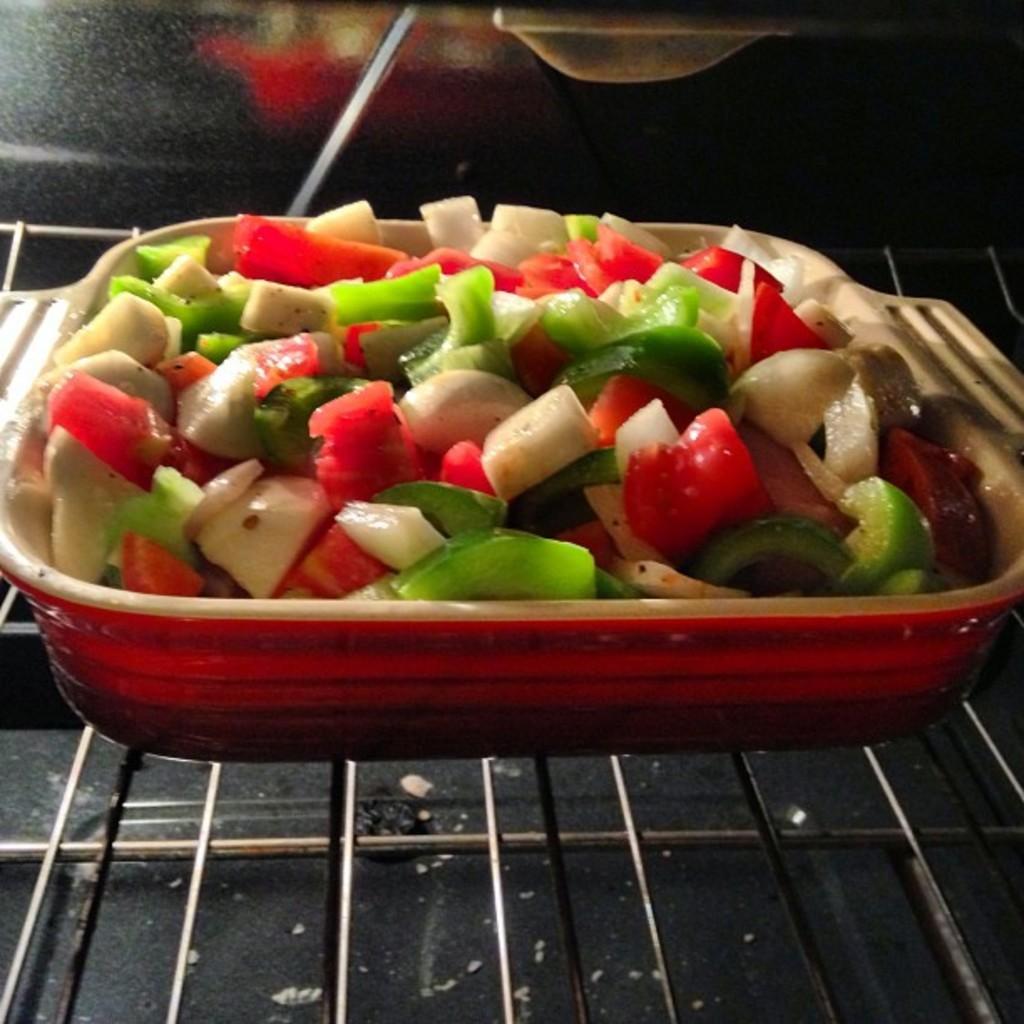Can you describe this image briefly? In this image we can see a bowl containing cut vegetables placed on the grill. 